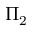Convert formula to latex. <formula><loc_0><loc_0><loc_500><loc_500>\Pi _ { 2 }</formula> 